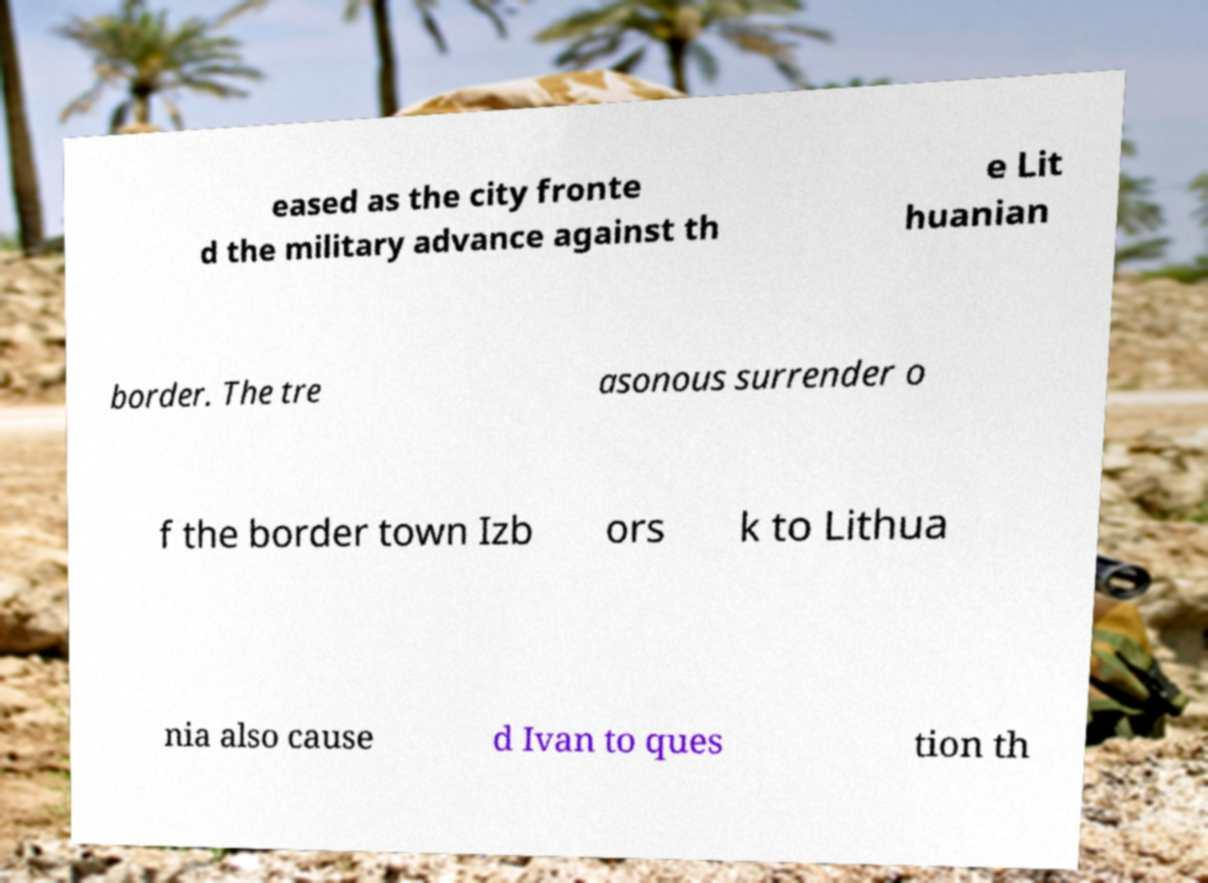Please read and relay the text visible in this image. What does it say? eased as the city fronte d the military advance against th e Lit huanian border. The tre asonous surrender o f the border town Izb ors k to Lithua nia also cause d Ivan to ques tion th 